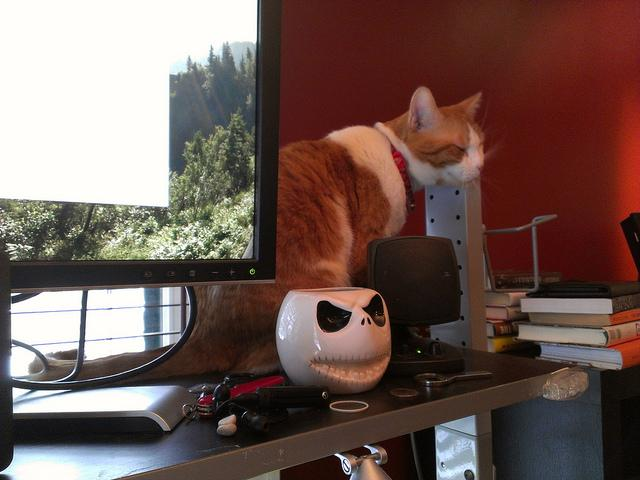What word is appropriate to describe the animal near the books?

Choices:
A) squid
B) invertebrate
C) mammal
D) mollusk mammal 